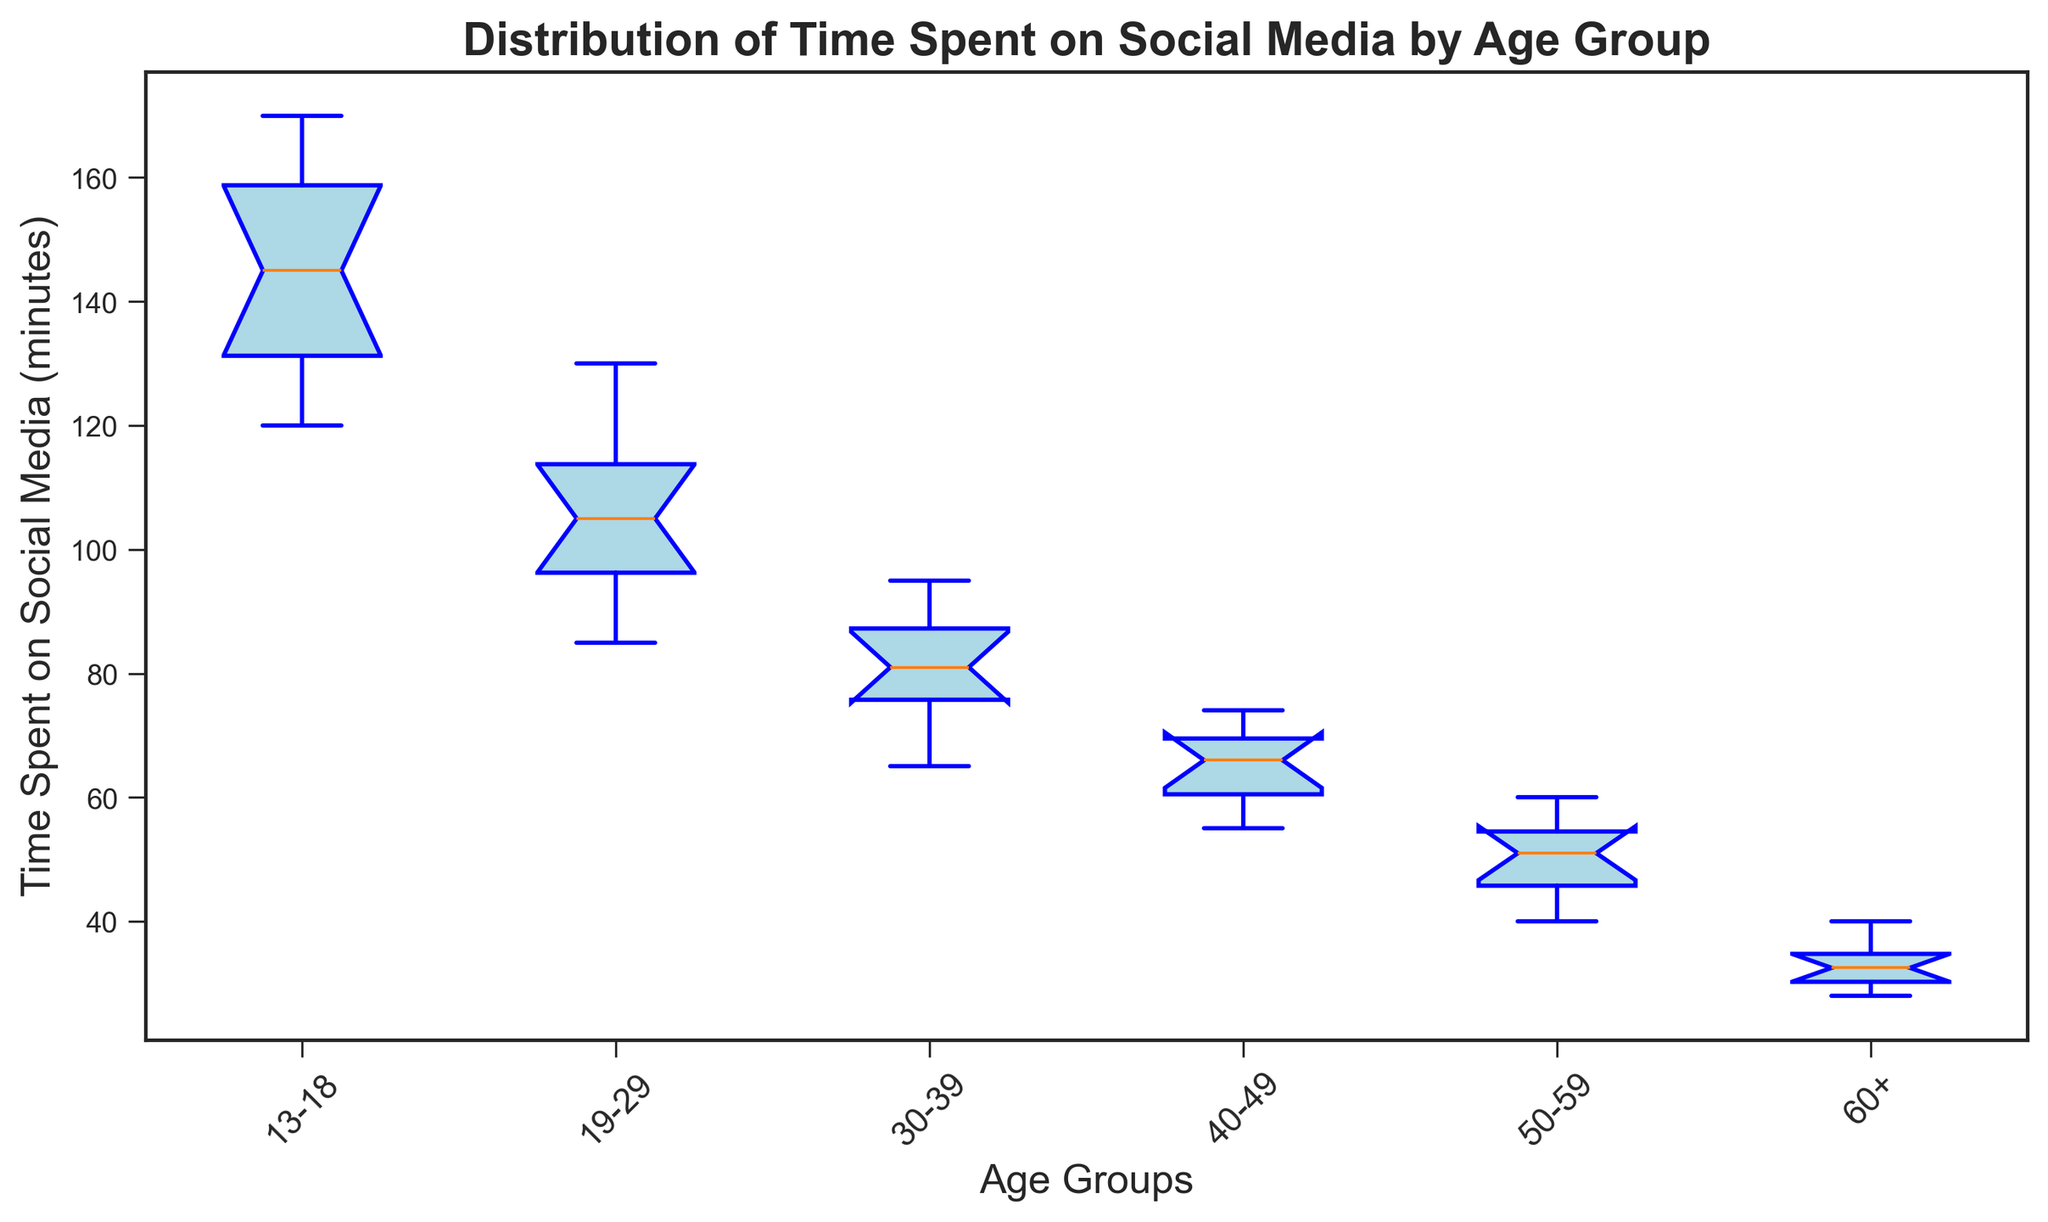What is the median time spent on social media for the 19-29 age group? The median for the 19-29 age group is the middle value when the data points are ordered. The ordered times are [85, 90, 95, 100, 105, 105, 110, 115, 120, 130]. The median is the average of the 5th and 6th values, (105+105)/2 = 105.
Answer: 105 Which age group has the highest median time spent on social media? To find the highest median, we compare the medians for each group. The medians are: 13-18 (137.5), 19-29 (105), 30-39 (81), 40-49 (66.5), 50-59 (51), 60+ (32.5). The highest median is for the 13-18 age group.
Answer: 13-18 Is there an age group where the median time spent on social media is exactly 60 minutes? By checking the medians, we see: 13-18 (137.5), 19-29 (105), 30-39 (81), 40-49 (66.5), 50-59 (51), 60+ (32.5). None of them have a median of exactly 60 minutes.
Answer: No Which age group has the smallest interquartile range (IQR) for time spent on social media? The IQR is the difference between the upper quartile (Q3) and lower quartile (Q1) in the box plot. Visually comparing the lengths of the boxes, 60+ has the smallest IQR.
Answer: 60+ How does the variability in time spent on social media compare between the 30-39 and 50-59 age groups? Variability can be seen from the length of the boxes (IQR) and the spread of the whiskers. The IQR for 30-39 is larger than 50-59, and the whiskers (range) are also longer for 30-39. Therefore, 30-39 has higher variability.
Answer: 30-39 has higher variability Which age group's upper whisker (maximum value excluding outliers) is higher, 19-29 or 40-49? The upper whisker on the box plot reaches the maximum value excluding outliers. For 19-29, the upper whisker is at 130, and for 40-49, it is at 74.
Answer: 19-29 What is the range of time spent on social media for the 13-18 age group? The range is the difference between the maximum and minimum values. For 13-18, the minimum is 120 and the maximum is 170. The range is 170 - 120 = 50.
Answer: 50 Are there any visible outliers in the 50-59 age group? Outliers are displayed as individual points outside the whiskers in a box plot. Upon inspection, there are no points outside the whiskers for 50-59.
Answer: No Which age group has the lowest lower quartile (Q1) value, indicating the least time spent on social media at the 25th percentile? By comparing the positions of the lower parts of the boxes, the 60+ age group has the lowest Q1 value since its box starts the lowest.
Answer: 60+ Which age group shows a noticeable skewness in their distribution of time spent on social media? Skewness in a box plot is indicated by the median line not being centered in the box or unequal whisker lengths. The 13-18 group shows a noticeable skew with a longer upper whisker and a median closer to the lower quartile.
Answer: 13-18 